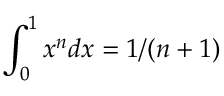Convert formula to latex. <formula><loc_0><loc_0><loc_500><loc_500>\int _ { 0 } ^ { 1 } x ^ { n } d x = 1 / ( n + 1 )</formula> 